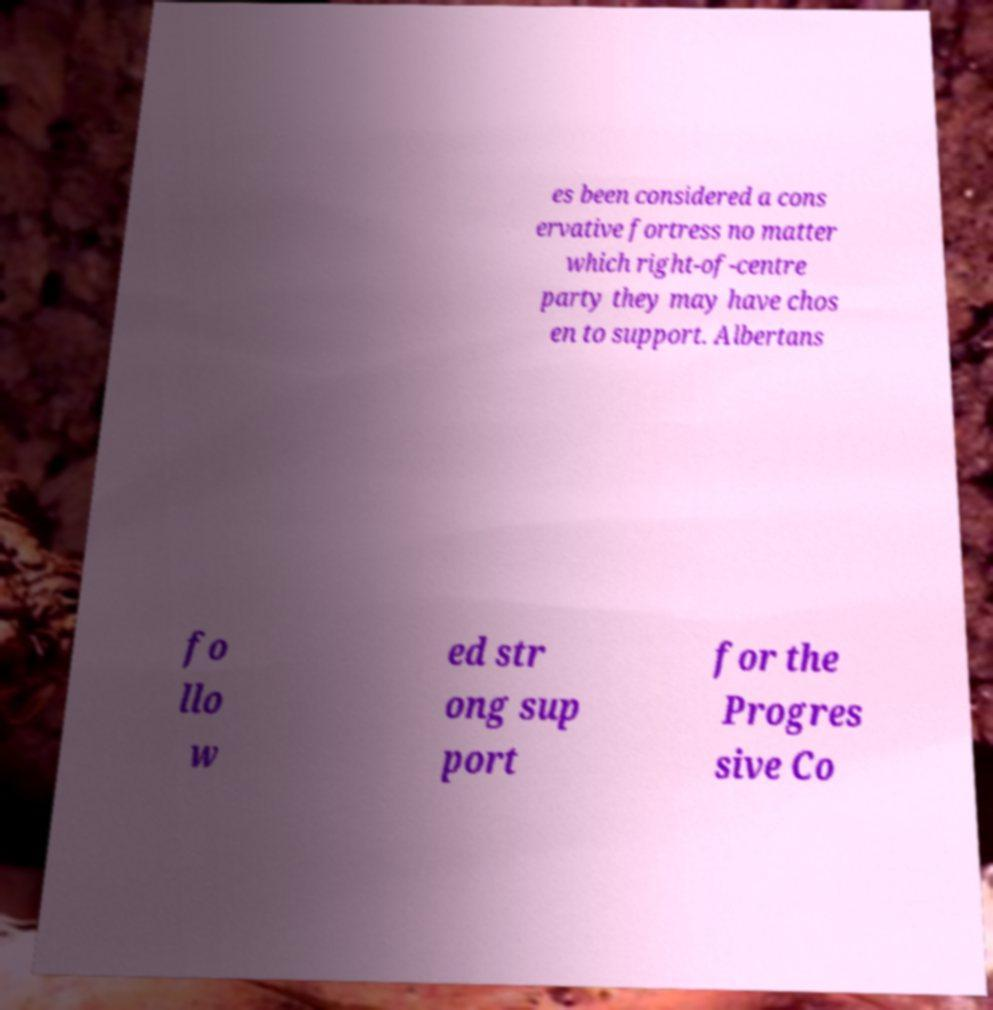Please read and relay the text visible in this image. What does it say? es been considered a cons ervative fortress no matter which right-of-centre party they may have chos en to support. Albertans fo llo w ed str ong sup port for the Progres sive Co 